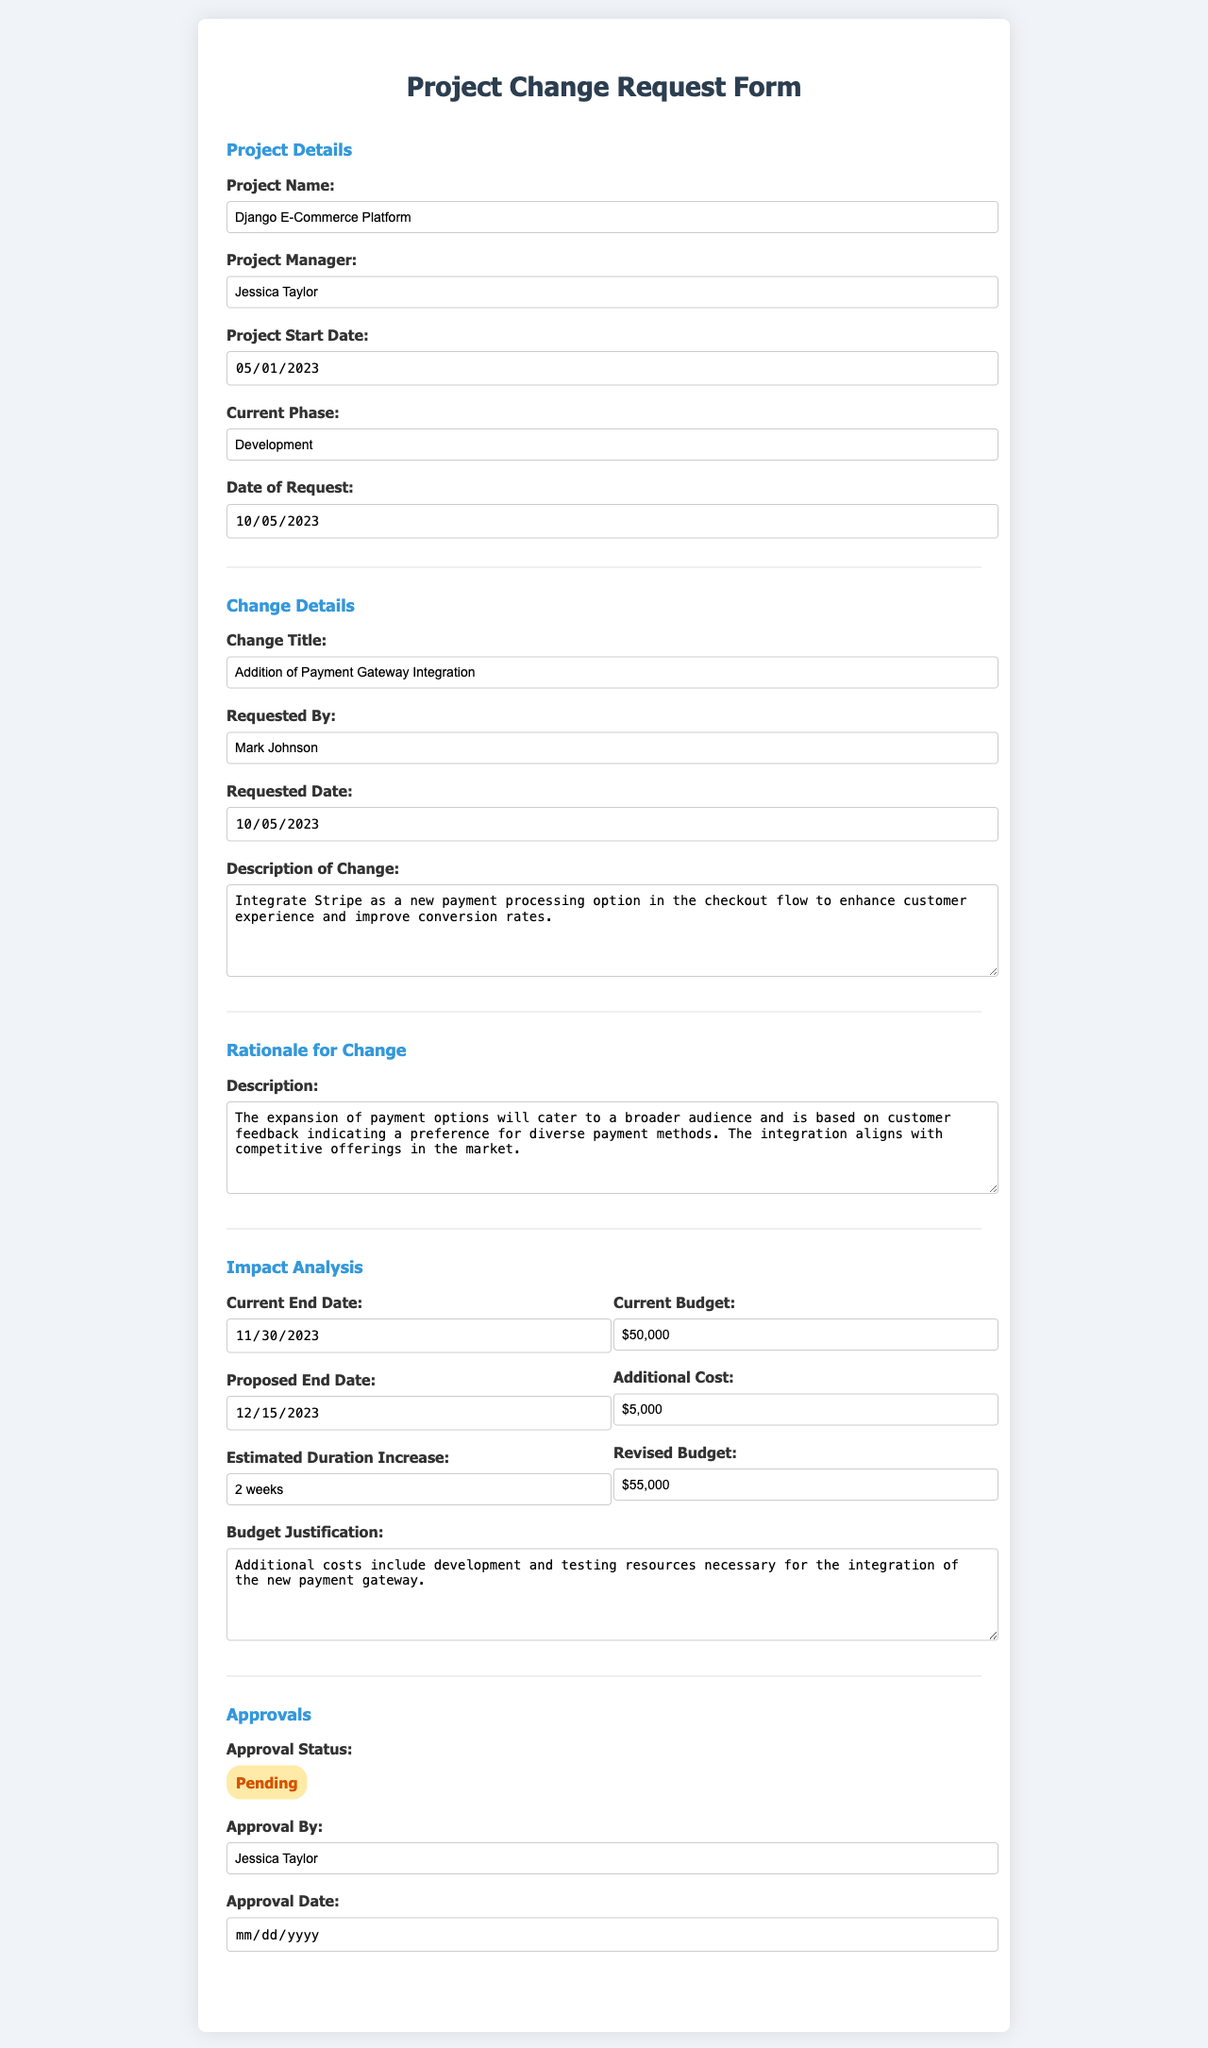What is the project name? The project name is mentioned in the "Project Details" section of the form.
Answer: Django E-Commerce Platform Who is the project manager? The project manager's name is listed under "Project Details".
Answer: Jessica Taylor What is the current phase of the project? The current phase of the project is specified in the "Project Details" section.
Answer: Development What is the requested change's title? The title of the requested change can be found in the "Change Details" section of the form.
Answer: Addition of Payment Gateway Integration What is the rationale for the change? The rationale explanation is provided in the "Rationale for Change" section.
Answer: The expansion of payment options will cater to a broader audience and is based on customer feedback indicating a preference for diverse payment methods What is the current budget for the project? The current budget is noted under the "Impact Analysis" section.
Answer: $50,000 What is the additional cost for the proposed change? The additional cost can be found in the "Impact Analysis" section of the form.
Answer: $5,000 What is the proposed end date after the change? The proposed end date is located in the "Impact Analysis" section.
Answer: 2023-12-15 What is the approval status of the change request? The approval status is indicated in the "Approvals" section.
Answer: Pending What is the estimated duration increase for the project? The estimated duration increase is detailed in the "Impact Analysis" section.
Answer: 2 weeks 